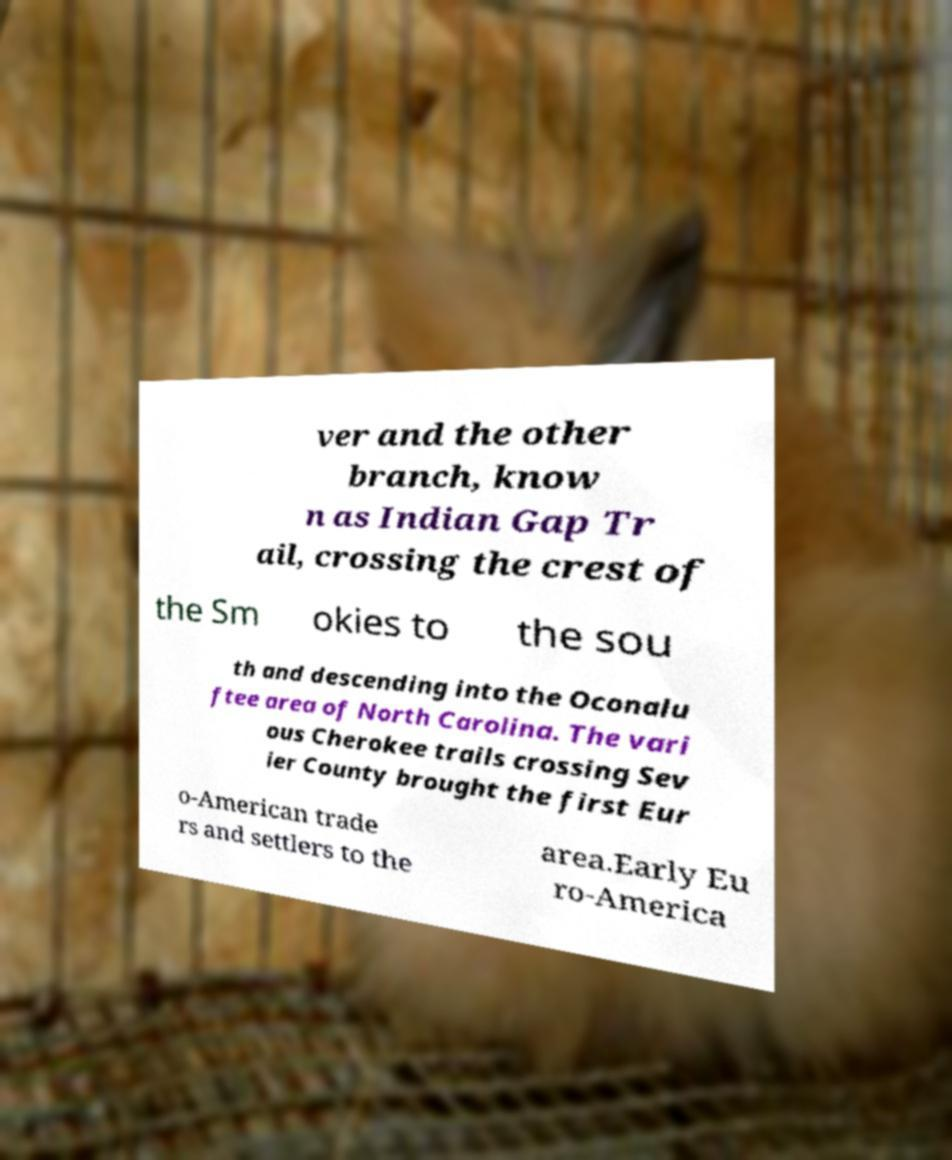Can you accurately transcribe the text from the provided image for me? ver and the other branch, know n as Indian Gap Tr ail, crossing the crest of the Sm okies to the sou th and descending into the Oconalu ftee area of North Carolina. The vari ous Cherokee trails crossing Sev ier County brought the first Eur o-American trade rs and settlers to the area.Early Eu ro-America 